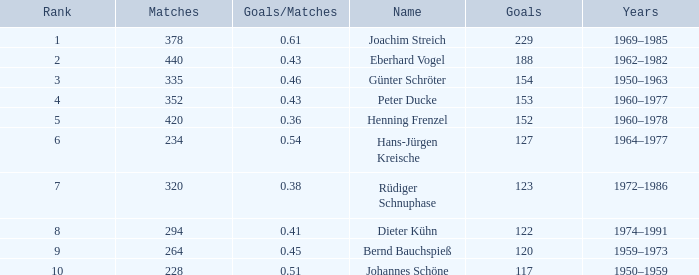What average goals have matches less than 228? None. 